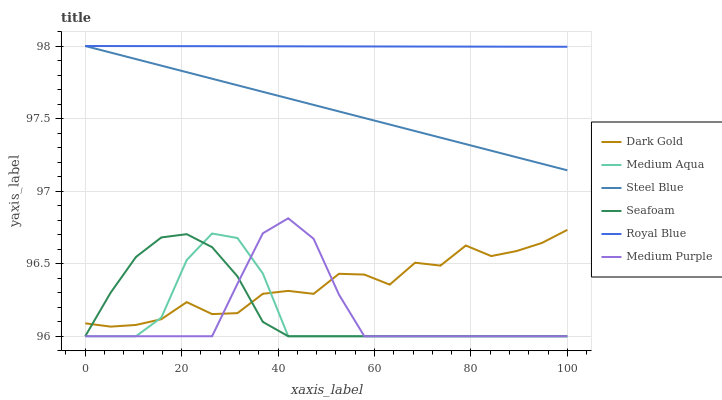Does Medium Aqua have the minimum area under the curve?
Answer yes or no. Yes. Does Royal Blue have the maximum area under the curve?
Answer yes or no. Yes. Does Seafoam have the minimum area under the curve?
Answer yes or no. No. Does Seafoam have the maximum area under the curve?
Answer yes or no. No. Is Steel Blue the smoothest?
Answer yes or no. Yes. Is Dark Gold the roughest?
Answer yes or no. Yes. Is Seafoam the smoothest?
Answer yes or no. No. Is Seafoam the roughest?
Answer yes or no. No. Does Seafoam have the lowest value?
Answer yes or no. Yes. Does Steel Blue have the lowest value?
Answer yes or no. No. Does Royal Blue have the highest value?
Answer yes or no. Yes. Does Seafoam have the highest value?
Answer yes or no. No. Is Seafoam less than Steel Blue?
Answer yes or no. Yes. Is Royal Blue greater than Medium Aqua?
Answer yes or no. Yes. Does Dark Gold intersect Medium Aqua?
Answer yes or no. Yes. Is Dark Gold less than Medium Aqua?
Answer yes or no. No. Is Dark Gold greater than Medium Aqua?
Answer yes or no. No. Does Seafoam intersect Steel Blue?
Answer yes or no. No. 